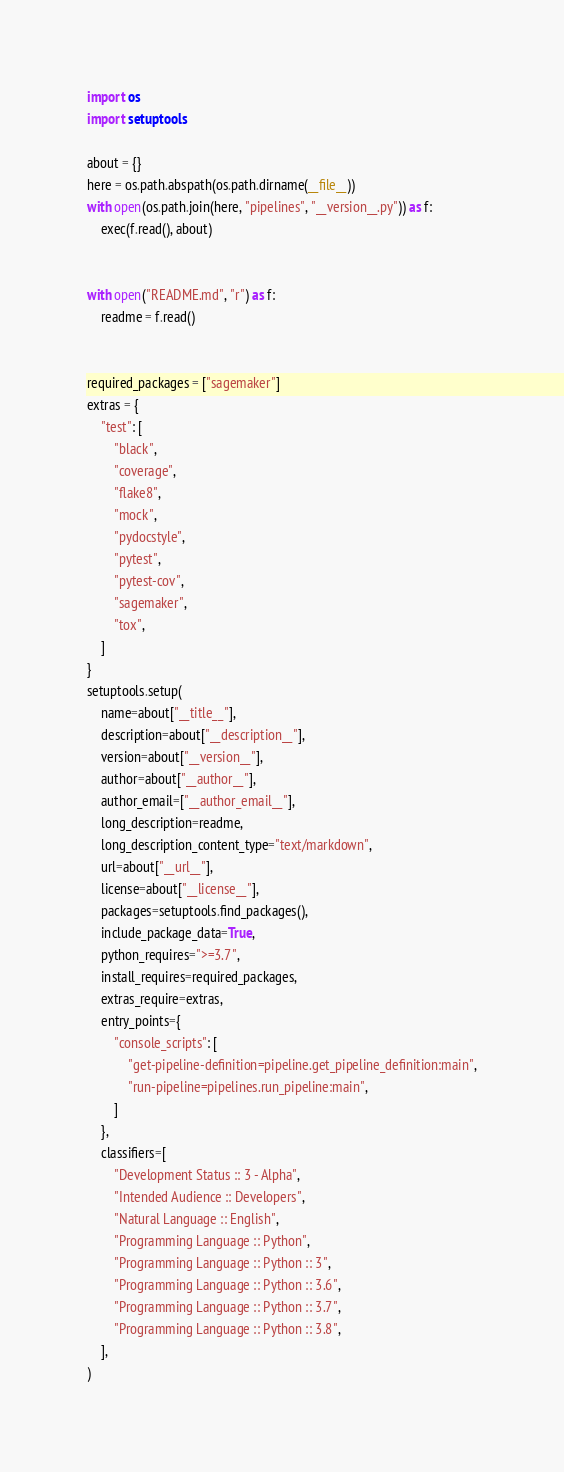Convert code to text. <code><loc_0><loc_0><loc_500><loc_500><_Python_>import os
import setuptools

about = {}
here = os.path.abspath(os.path.dirname(__file__))
with open(os.path.join(here, "pipelines", "__version__.py")) as f:
    exec(f.read(), about)


with open("README.md", "r") as f:
    readme = f.read()


required_packages = ["sagemaker"]
extras = {
    "test": [
        "black",
        "coverage",
        "flake8",
        "mock",
        "pydocstyle",
        "pytest",
        "pytest-cov",
        "sagemaker",
        "tox",
    ]
}
setuptools.setup(
    name=about["__title__"],
    description=about["__description__"],
    version=about["__version__"],
    author=about["__author__"],
    author_email=["__author_email__"],
    long_description=readme,
    long_description_content_type="text/markdown",
    url=about["__url__"],
    license=about["__license__"],
    packages=setuptools.find_packages(),
    include_package_data=True,
    python_requires=">=3.7",
    install_requires=required_packages,
    extras_require=extras,
    entry_points={
        "console_scripts": [
            "get-pipeline-definition=pipeline.get_pipeline_definition:main",
            "run-pipeline=pipelines.run_pipeline:main",
        ]
    },
    classifiers=[
        "Development Status :: 3 - Alpha",
        "Intended Audience :: Developers",
        "Natural Language :: English",
        "Programming Language :: Python",
        "Programming Language :: Python :: 3",
        "Programming Language :: Python :: 3.6",
        "Programming Language :: Python :: 3.7",
        "Programming Language :: Python :: 3.8",
    ],
)
</code> 